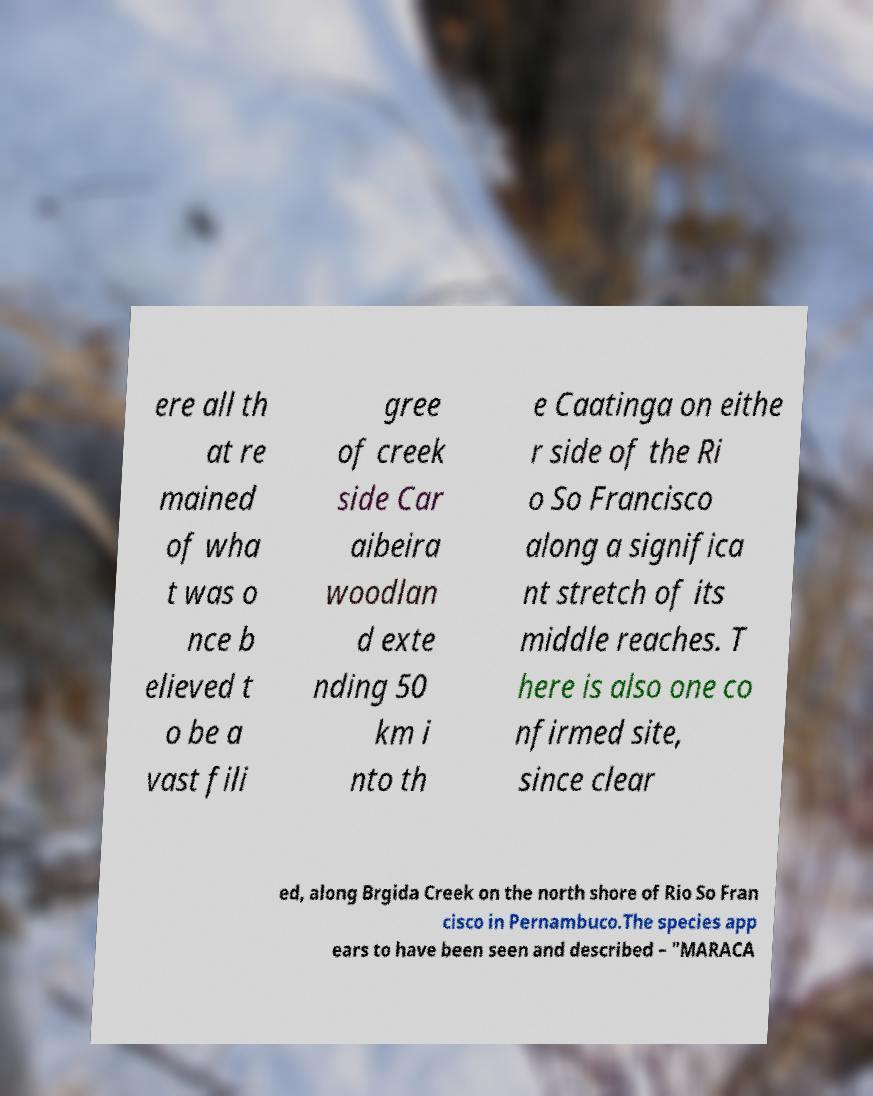I need the written content from this picture converted into text. Can you do that? ere all th at re mained of wha t was o nce b elieved t o be a vast fili gree of creek side Car aibeira woodlan d exte nding 50 km i nto th e Caatinga on eithe r side of the Ri o So Francisco along a significa nt stretch of its middle reaches. T here is also one co nfirmed site, since clear ed, along Brgida Creek on the north shore of Rio So Fran cisco in Pernambuco.The species app ears to have been seen and described – "MARACA 